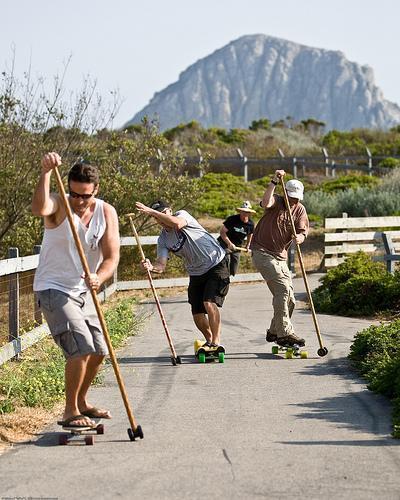How many people are wearing sunglasses?
Give a very brief answer. 1. 